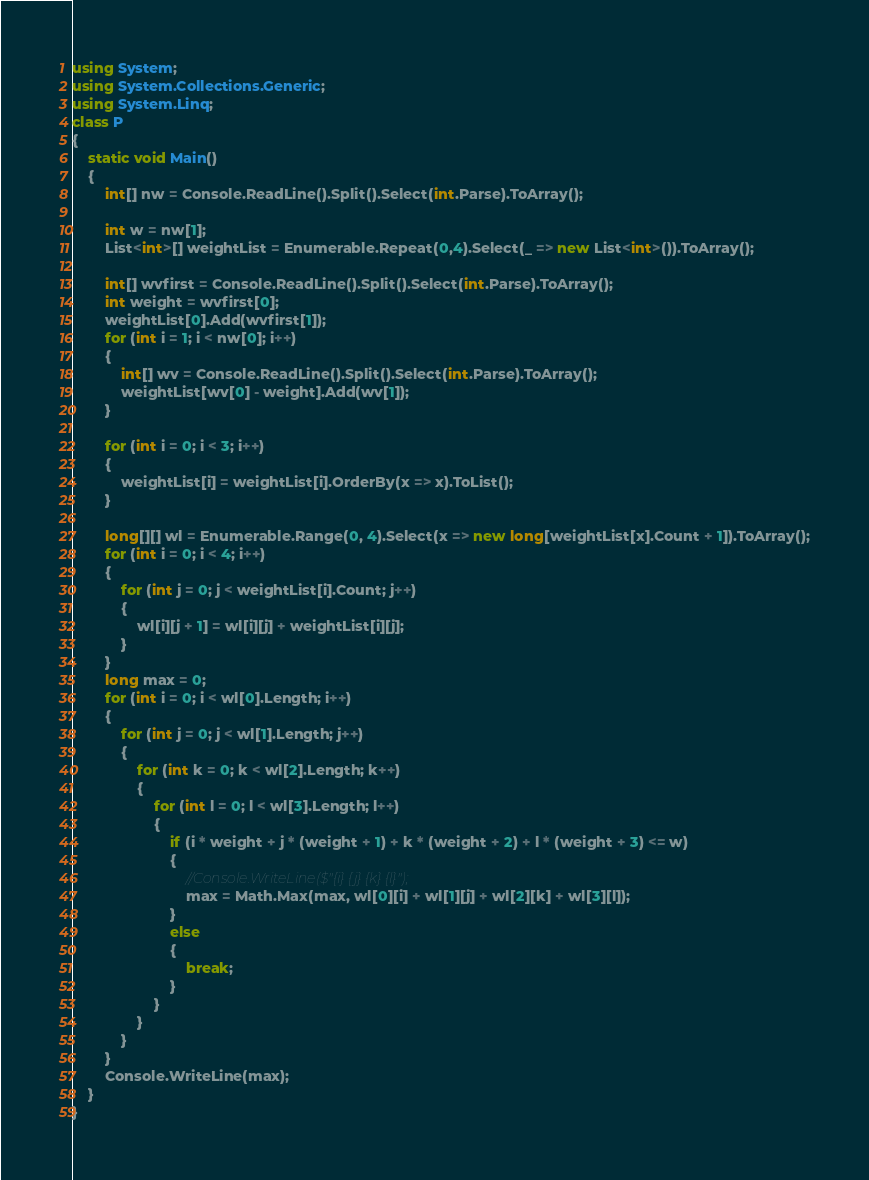<code> <loc_0><loc_0><loc_500><loc_500><_C#_>using System;
using System.Collections.Generic;
using System.Linq;
class P
{
    static void Main()
    {
        int[] nw = Console.ReadLine().Split().Select(int.Parse).ToArray();

        int w = nw[1];
        List<int>[] weightList = Enumerable.Repeat(0,4).Select(_ => new List<int>()).ToArray();

        int[] wvfirst = Console.ReadLine().Split().Select(int.Parse).ToArray();
        int weight = wvfirst[0];
        weightList[0].Add(wvfirst[1]);
        for (int i = 1; i < nw[0]; i++)
        {
            int[] wv = Console.ReadLine().Split().Select(int.Parse).ToArray();
            weightList[wv[0] - weight].Add(wv[1]);
        }

        for (int i = 0; i < 3; i++)
        {
            weightList[i] = weightList[i].OrderBy(x => x).ToList();
        }

        long[][] wl = Enumerable.Range(0, 4).Select(x => new long[weightList[x].Count + 1]).ToArray();
        for (int i = 0; i < 4; i++)
        {
            for (int j = 0; j < weightList[i].Count; j++)
            {
                wl[i][j + 1] = wl[i][j] + weightList[i][j];
            }
        }
        long max = 0;
        for (int i = 0; i < wl[0].Length; i++)
        {
            for (int j = 0; j < wl[1].Length; j++)
            {
                for (int k = 0; k < wl[2].Length; k++)
                {
                    for (int l = 0; l < wl[3].Length; l++)
                    {
                        if (i * weight + j * (weight + 1) + k * (weight + 2) + l * (weight + 3) <= w)
                        {
                            //Console.WriteLine($"{i} {j} {k} {l}");
                            max = Math.Max(max, wl[0][i] + wl[1][j] + wl[2][k] + wl[3][l]);
                        }
                        else
                        {
                            break;
                        }
                    }
                }
            }
        }
        Console.WriteLine(max);
    }
}</code> 